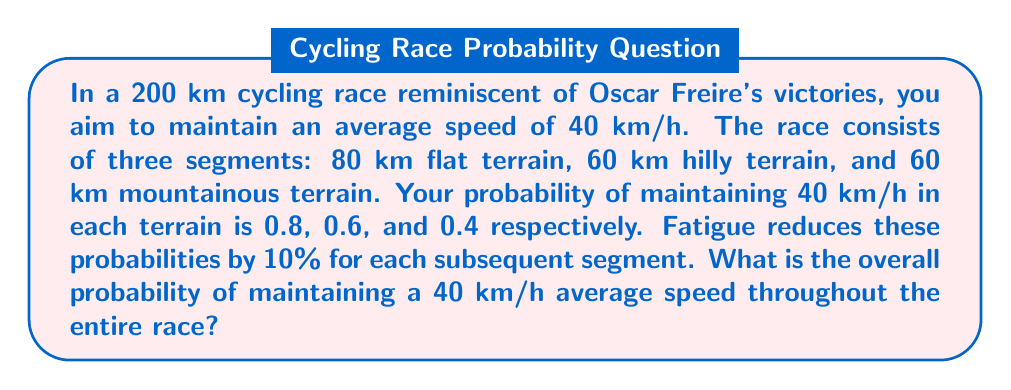Can you answer this question? Let's approach this step-by-step:

1) First, let's calculate the probabilities for each segment, considering fatigue:

   Flat terrain (1st segment): $P_1 = 0.8$
   Hilly terrain (2nd segment): $P_2 = 0.6 \times 0.9 = 0.54$
   Mountainous terrain (3rd segment): $P_3 = 0.4 \times 0.9 \times 0.9 = 0.324$

2) To maintain the average speed throughout the entire race, you need to succeed in all three segments. This is a case of independent events, so we multiply the probabilities:

   $$P(\text{entire race}) = P_1 \times P_2 \times P_3$$

3) Substituting the values:

   $$P(\text{entire race}) = 0.8 \times 0.54 \times 0.324$$

4) Calculate:

   $$P(\text{entire race}) = 0.13996$$

5) Round to three decimal places:

   $$P(\text{entire race}) \approx 0.140$$

Therefore, the probability of maintaining a 40 km/h average speed throughout the entire race is approximately 0.140 or 14.0%.
Answer: 0.140 